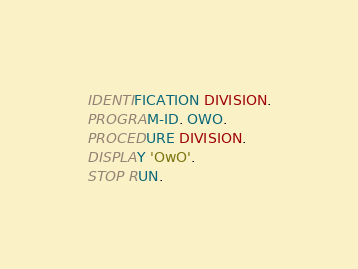Convert code to text. <code><loc_0><loc_0><loc_500><loc_500><_COBOL_>IDENTIFICATION DIVISION.
PROGRAM-ID. OWO.
PROCEDURE DIVISION.
DISPLAY 'OwO'.
STOP RUN.
</code> 